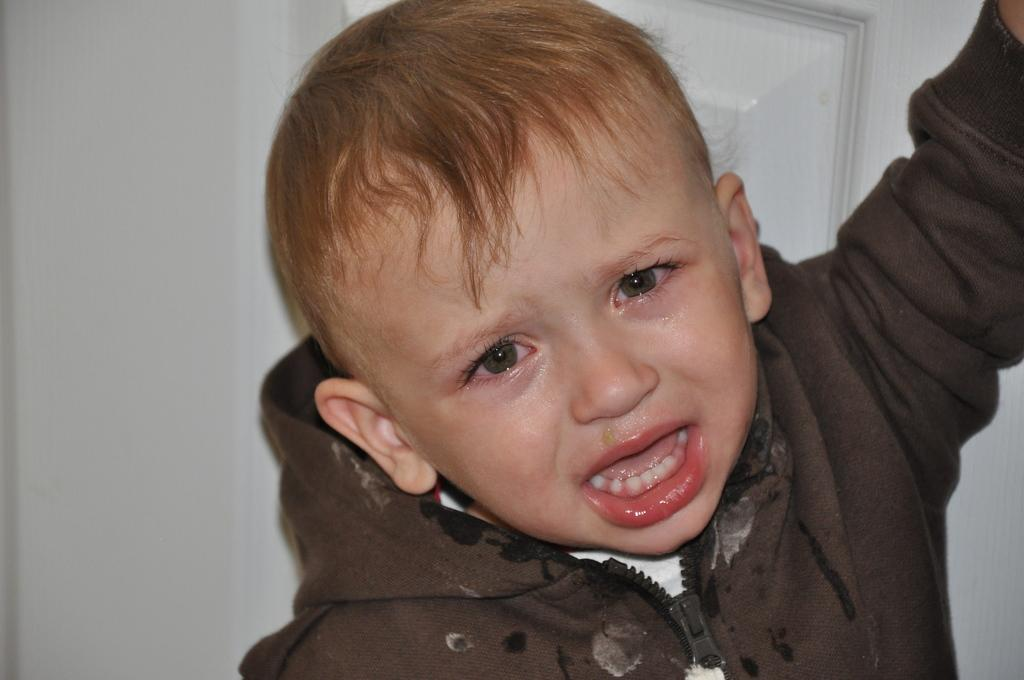What is the main subject of the image? The main subject of the image is a small boy. What is the boy doing in the image? The boy is crying in the image. What is the boy wearing in the image? The boy is wearing a jacket in the image. What can be seen in the background of the image? There is a door and a white wall in the background of the image. What type of science is being conducted in the image? There is no science being conducted in the image; it features a small boy who is crying. Can you see any tigers in the image? There are no tigers present in the image. How many chairs are visible in the image? There are no chairs visible in the image. 